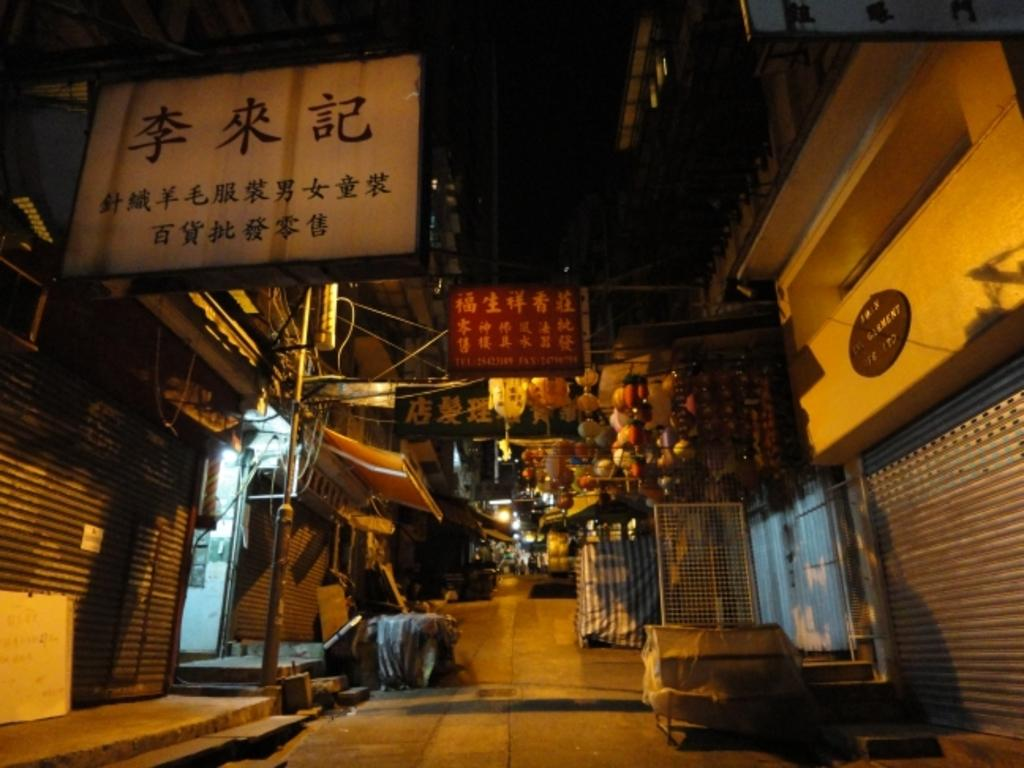What type of structures can be seen in the image? There are buildings in the image. What else is present in the image besides buildings? There are poles, name boards, paper lanterns, and lights visible in the image. What can be seen in the sky in the image? The sky is visible in the image. How does the jelly interact with the ocean in the image? There is no jelly or ocean present in the image. Can you describe how the lights are being pulled in the image? There is no indication of lights being pulled in the image; they are stationary. 